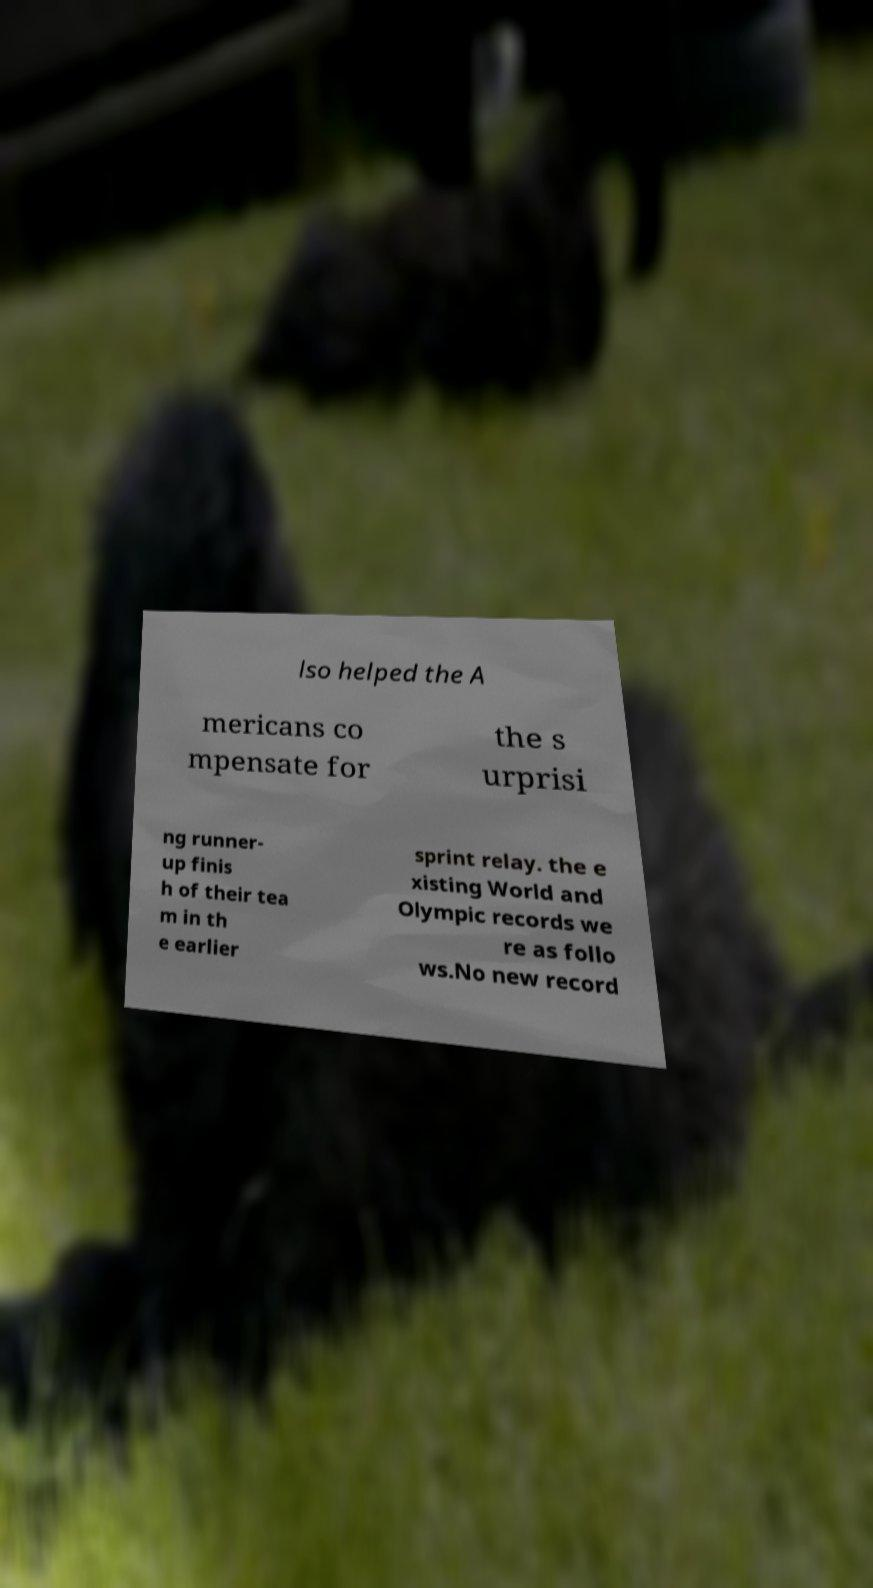For documentation purposes, I need the text within this image transcribed. Could you provide that? lso helped the A mericans co mpensate for the s urprisi ng runner- up finis h of their tea m in th e earlier sprint relay. the e xisting World and Olympic records we re as follo ws.No new record 